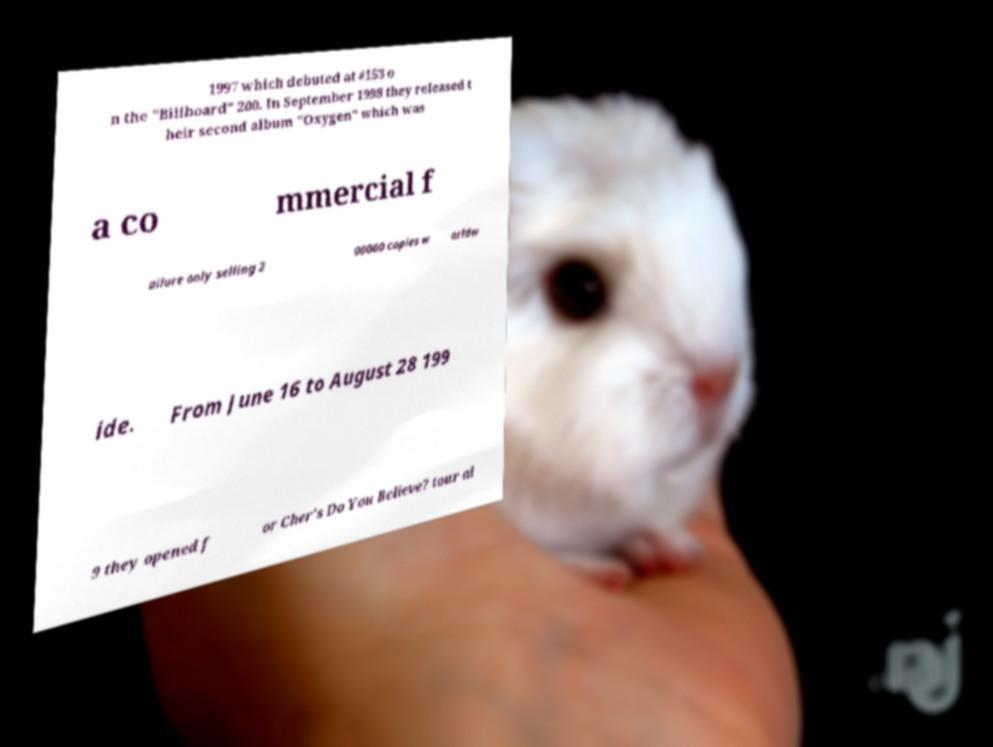For documentation purposes, I need the text within this image transcribed. Could you provide that? 1997 which debuted at #153 o n the "Billboard" 200. In September 1998 they released t heir second album "Oxygen" which was a co mmercial f ailure only selling 2 00000 copies w orldw ide. From June 16 to August 28 199 9 they opened f or Cher's Do You Believe? tour al 